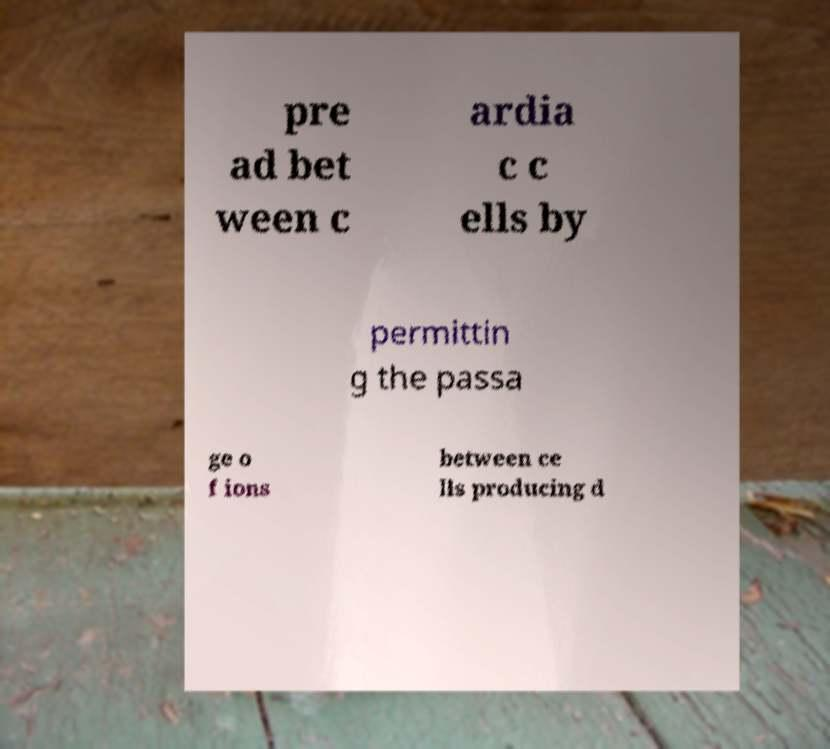Could you extract and type out the text from this image? pre ad bet ween c ardia c c ells by permittin g the passa ge o f ions between ce lls producing d 